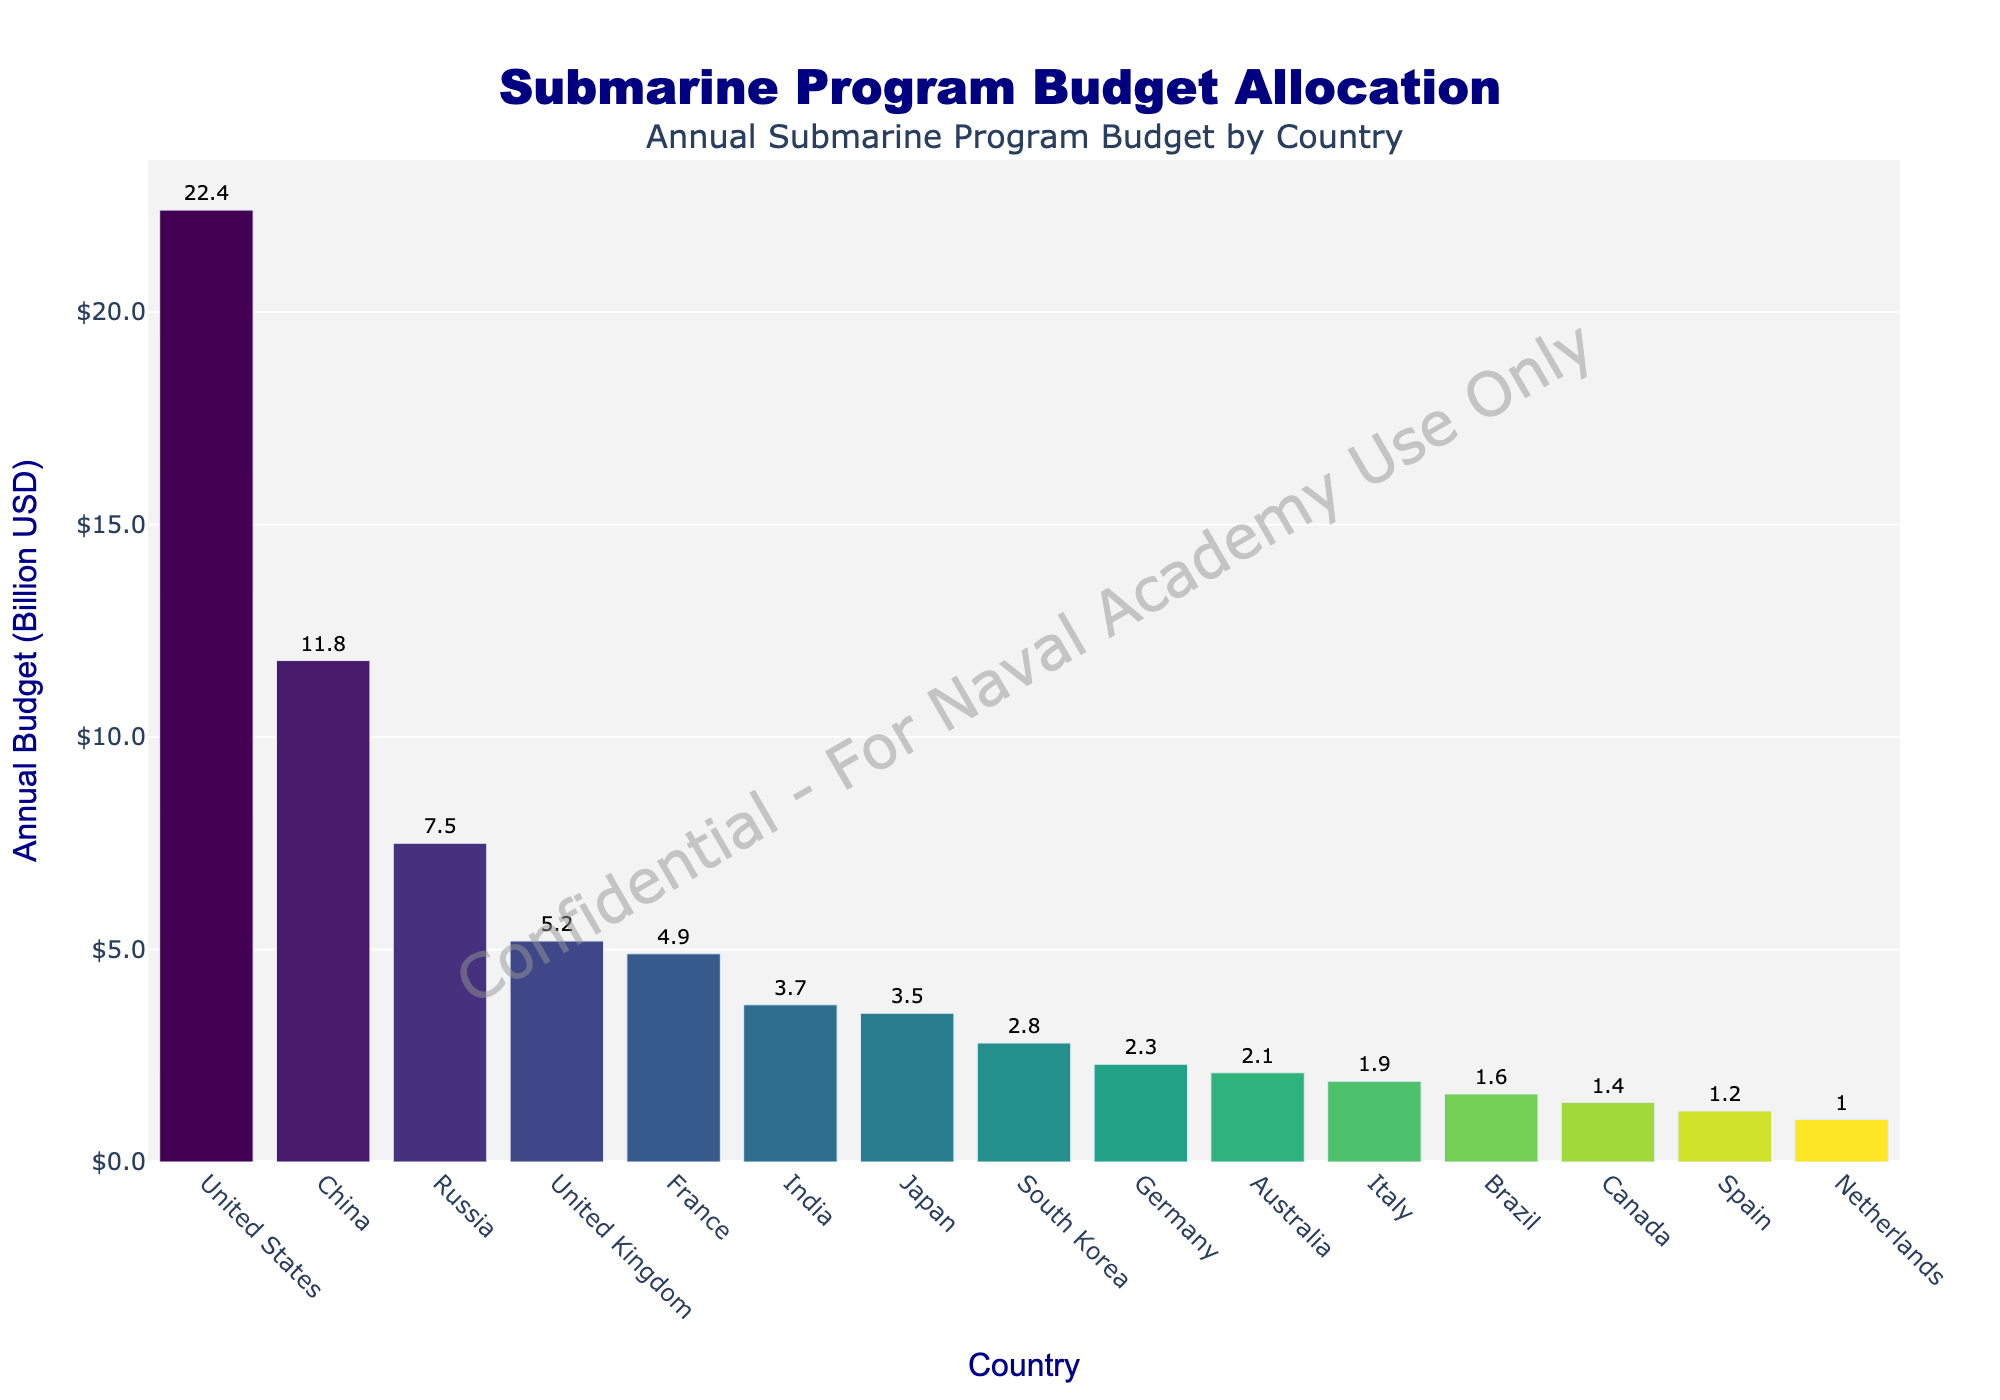Which country has the highest annual budget for submarine programs? The country with the tallest bar in the graph is the United States.
Answer: United States What is the combined budget of Russia and India? From the graph, Russia’s budget is $7.5 billion and India’s budget is $3.7 billion. Their combined budget is $7.5 billion + $3.7 billion = $11.2 billion.
Answer: $11.2 billion How much more is the United States' budget compared to China? The United States' budget is $22.4 billion, while China's is $11.8 billion. The difference is $22.4 billion - $11.8 billion = $10.6 billion.
Answer: $10.6 billion What is the average budget allocation across the listed countries? Summing all the budgets: 22.4 + 11.8 + 7.5 + 5.2 + 4.9 + 3.7 + 3.5 + 2.8 + 2.3 + 2.1 + 1.9 + 1.6 + 1.4 + 1.2 + 1.0 = 71.3 billion. There are 15 countries, so the average budget is 71.3 / 15 ≈ 4.75 billion USD.
Answer: Approximately 4.75 billion USD Among the listed countries, which ones have a budget allocation of less than $2 billion? From the chart, the countries with budgets less than $2 billion are Brazil ($1.6 billion), Canada ($1.4 billion), Spain ($1.2 billion), and Netherlands ($1.0 billion).
Answer: Brazil, Canada, Spain, Netherlands Which countries have a higher budget allocation than Japan but lower than France? From the graph, South Korea ($2.8 billion), Germany ($2.3 billion), and Australia ($2.1 billion) have higher budgets than Japan ($3.5 billion) but lower than France ($4.9 billion).
Answer: South Korea, Germany, Australia What is the total budget of the top three countries combined? The top three countries by budget are the United States ($22.4 billion), China ($11.8 billion), and Russia ($7.5 billion). Their combined budget is $22.4 billion + $11.8 billion + $7.5 billion = $41.7 billion.
Answer: $41.7 billion How many countries have a budget allocation greater than $5 billion? By examining the graph, there are four countries with budgets greater than $5 billion: United States ($22.4 billion), China ($11.8 billion), Russia ($7.5 billion), and United Kingdom ($5.2 billion).
Answer: Four 